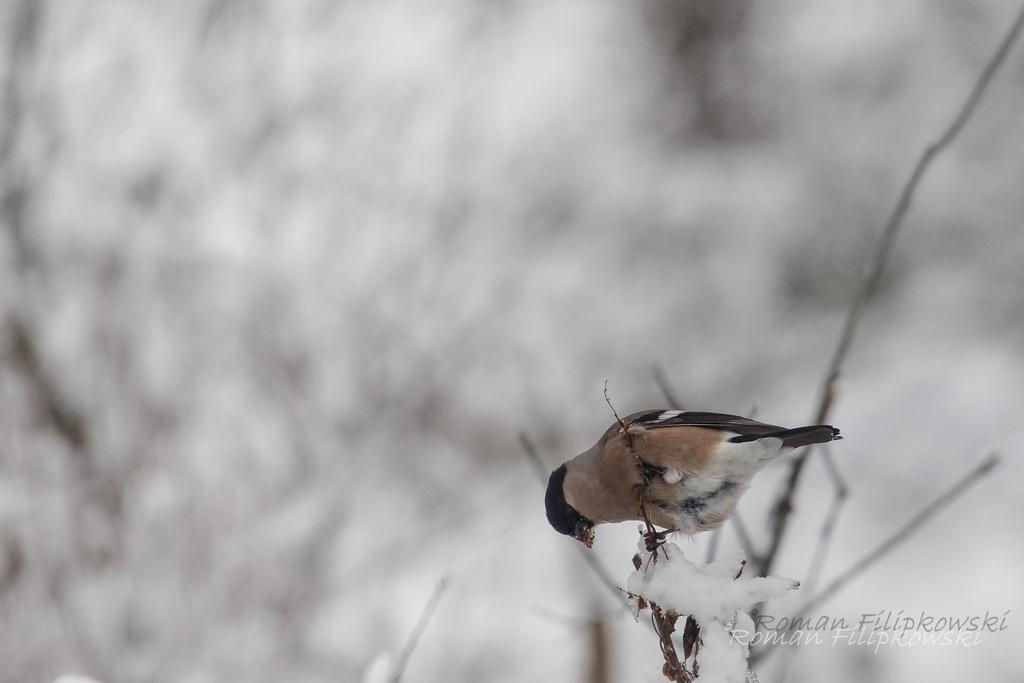What type of animal can be seen in the image? There is a bird in the image. Where is the bird located? The bird is on a tree. What colors can be observed on the bird? The bird has brown and black colors. What is the color of the background in the image? The background of the image is white. How is the image blurred? The image is blurred in the background. Can you see the vein on the rabbit's ear in the image? There is no rabbit present in the image, so it is not possible to see any veins on its ear. 